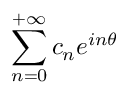Convert formula to latex. <formula><loc_0><loc_0><loc_500><loc_500>\sum _ { n = 0 } ^ { + \infty } c _ { n } e ^ { i n \theta }</formula> 